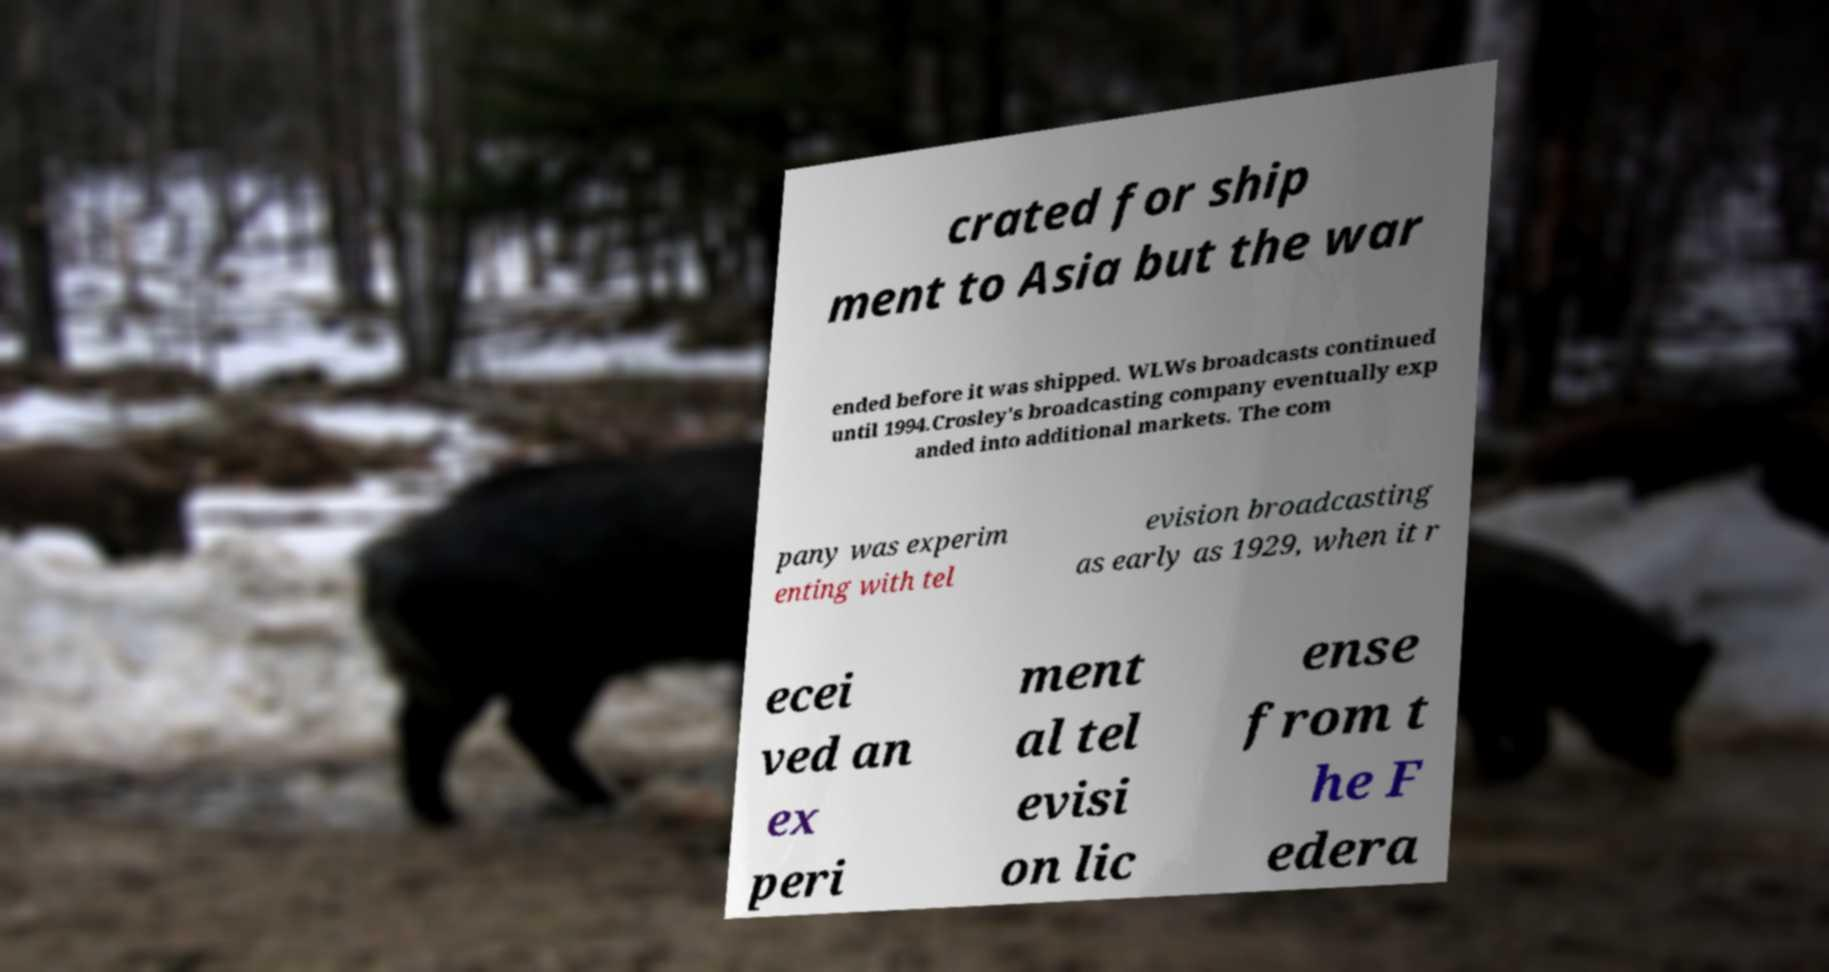Could you assist in decoding the text presented in this image and type it out clearly? crated for ship ment to Asia but the war ended before it was shipped. WLWs broadcasts continued until 1994.Crosley's broadcasting company eventually exp anded into additional markets. The com pany was experim enting with tel evision broadcasting as early as 1929, when it r ecei ved an ex peri ment al tel evisi on lic ense from t he F edera 